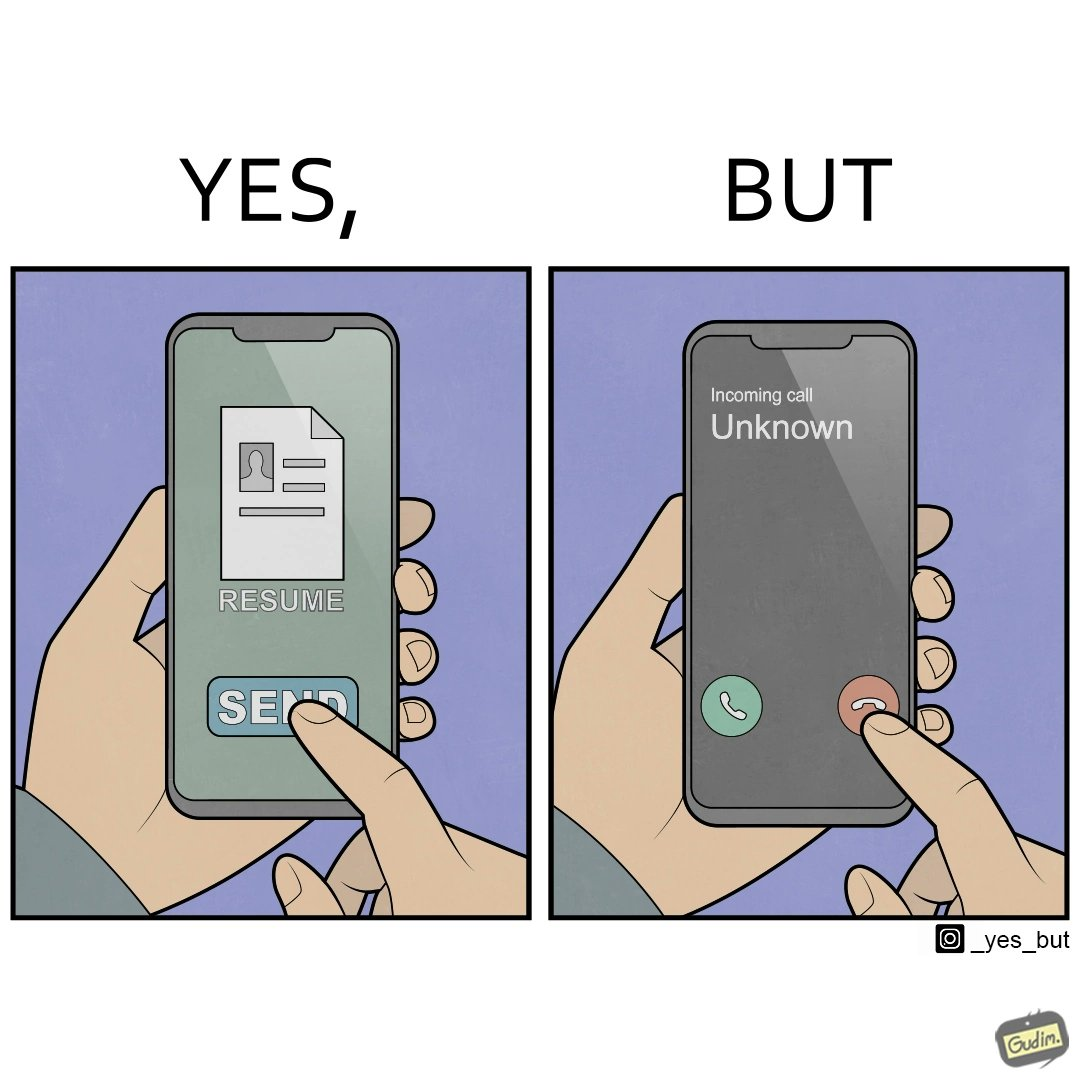Would you classify this image as satirical? Yes, this image is satirical. 